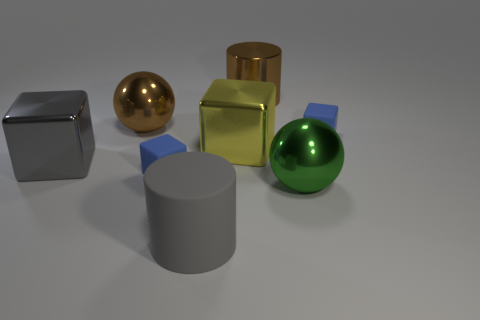The other object that is the same color as the large matte object is what size?
Your response must be concise. Large. What number of yellow things are either tiny objects or shiny things?
Offer a terse response. 1. What number of other things are there of the same shape as the green metal object?
Provide a succinct answer. 1. What shape is the large metallic object that is both to the right of the big yellow thing and behind the large yellow cube?
Ensure brevity in your answer.  Cylinder. There is a gray metal thing; are there any things behind it?
Give a very brief answer. Yes. There is another thing that is the same shape as the green object; what size is it?
Make the answer very short. Large. Are there any other things that have the same size as the gray matte cylinder?
Provide a short and direct response. Yes. Is the shape of the large gray rubber thing the same as the large green object?
Offer a very short reply. No. There is a gray thing that is on the right side of the metallic cube that is to the left of the large yellow metallic thing; what is its size?
Your answer should be compact. Large. What is the color of the other metallic object that is the same shape as the large yellow shiny thing?
Your answer should be compact. Gray. 